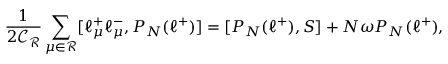Convert formula to latex. <formula><loc_0><loc_0><loc_500><loc_500>\frac { 1 } { 2 \mathcal { C _ { R } } } \sum _ { \mu \in \mathcal { R } } [ \ell _ { \mu } ^ { + } \ell _ { \mu } ^ { - } , P _ { N } ( \ell ^ { + } ) ] = [ P _ { N } ( \ell ^ { + } ) , S ] + N \omega P _ { N } ( \ell ^ { + } ) ,</formula> 